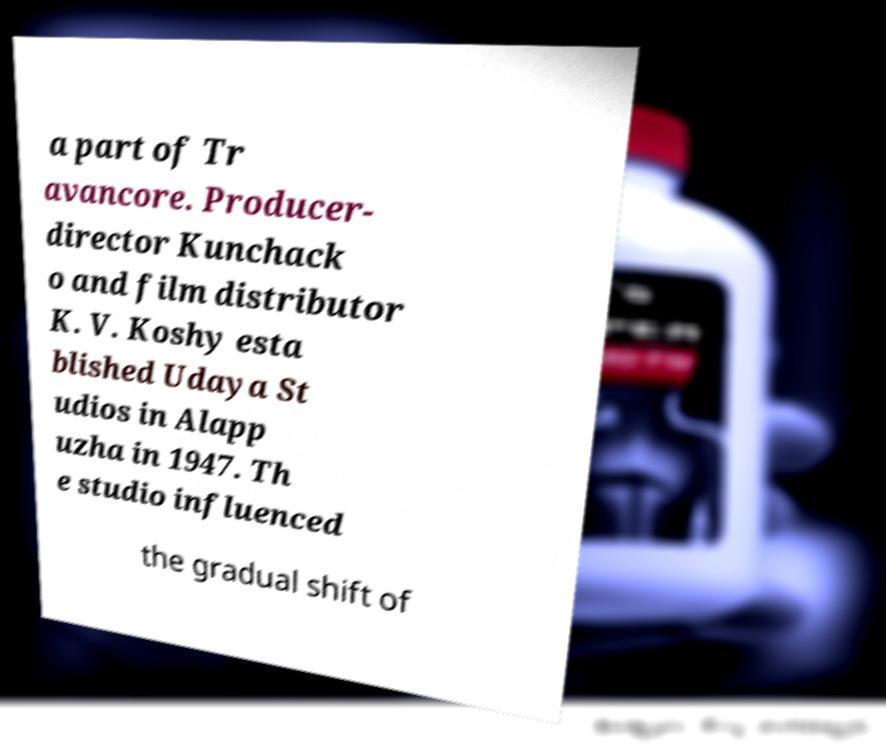Please read and relay the text visible in this image. What does it say? a part of Tr avancore. Producer- director Kunchack o and film distributor K. V. Koshy esta blished Udaya St udios in Alapp uzha in 1947. Th e studio influenced the gradual shift of 